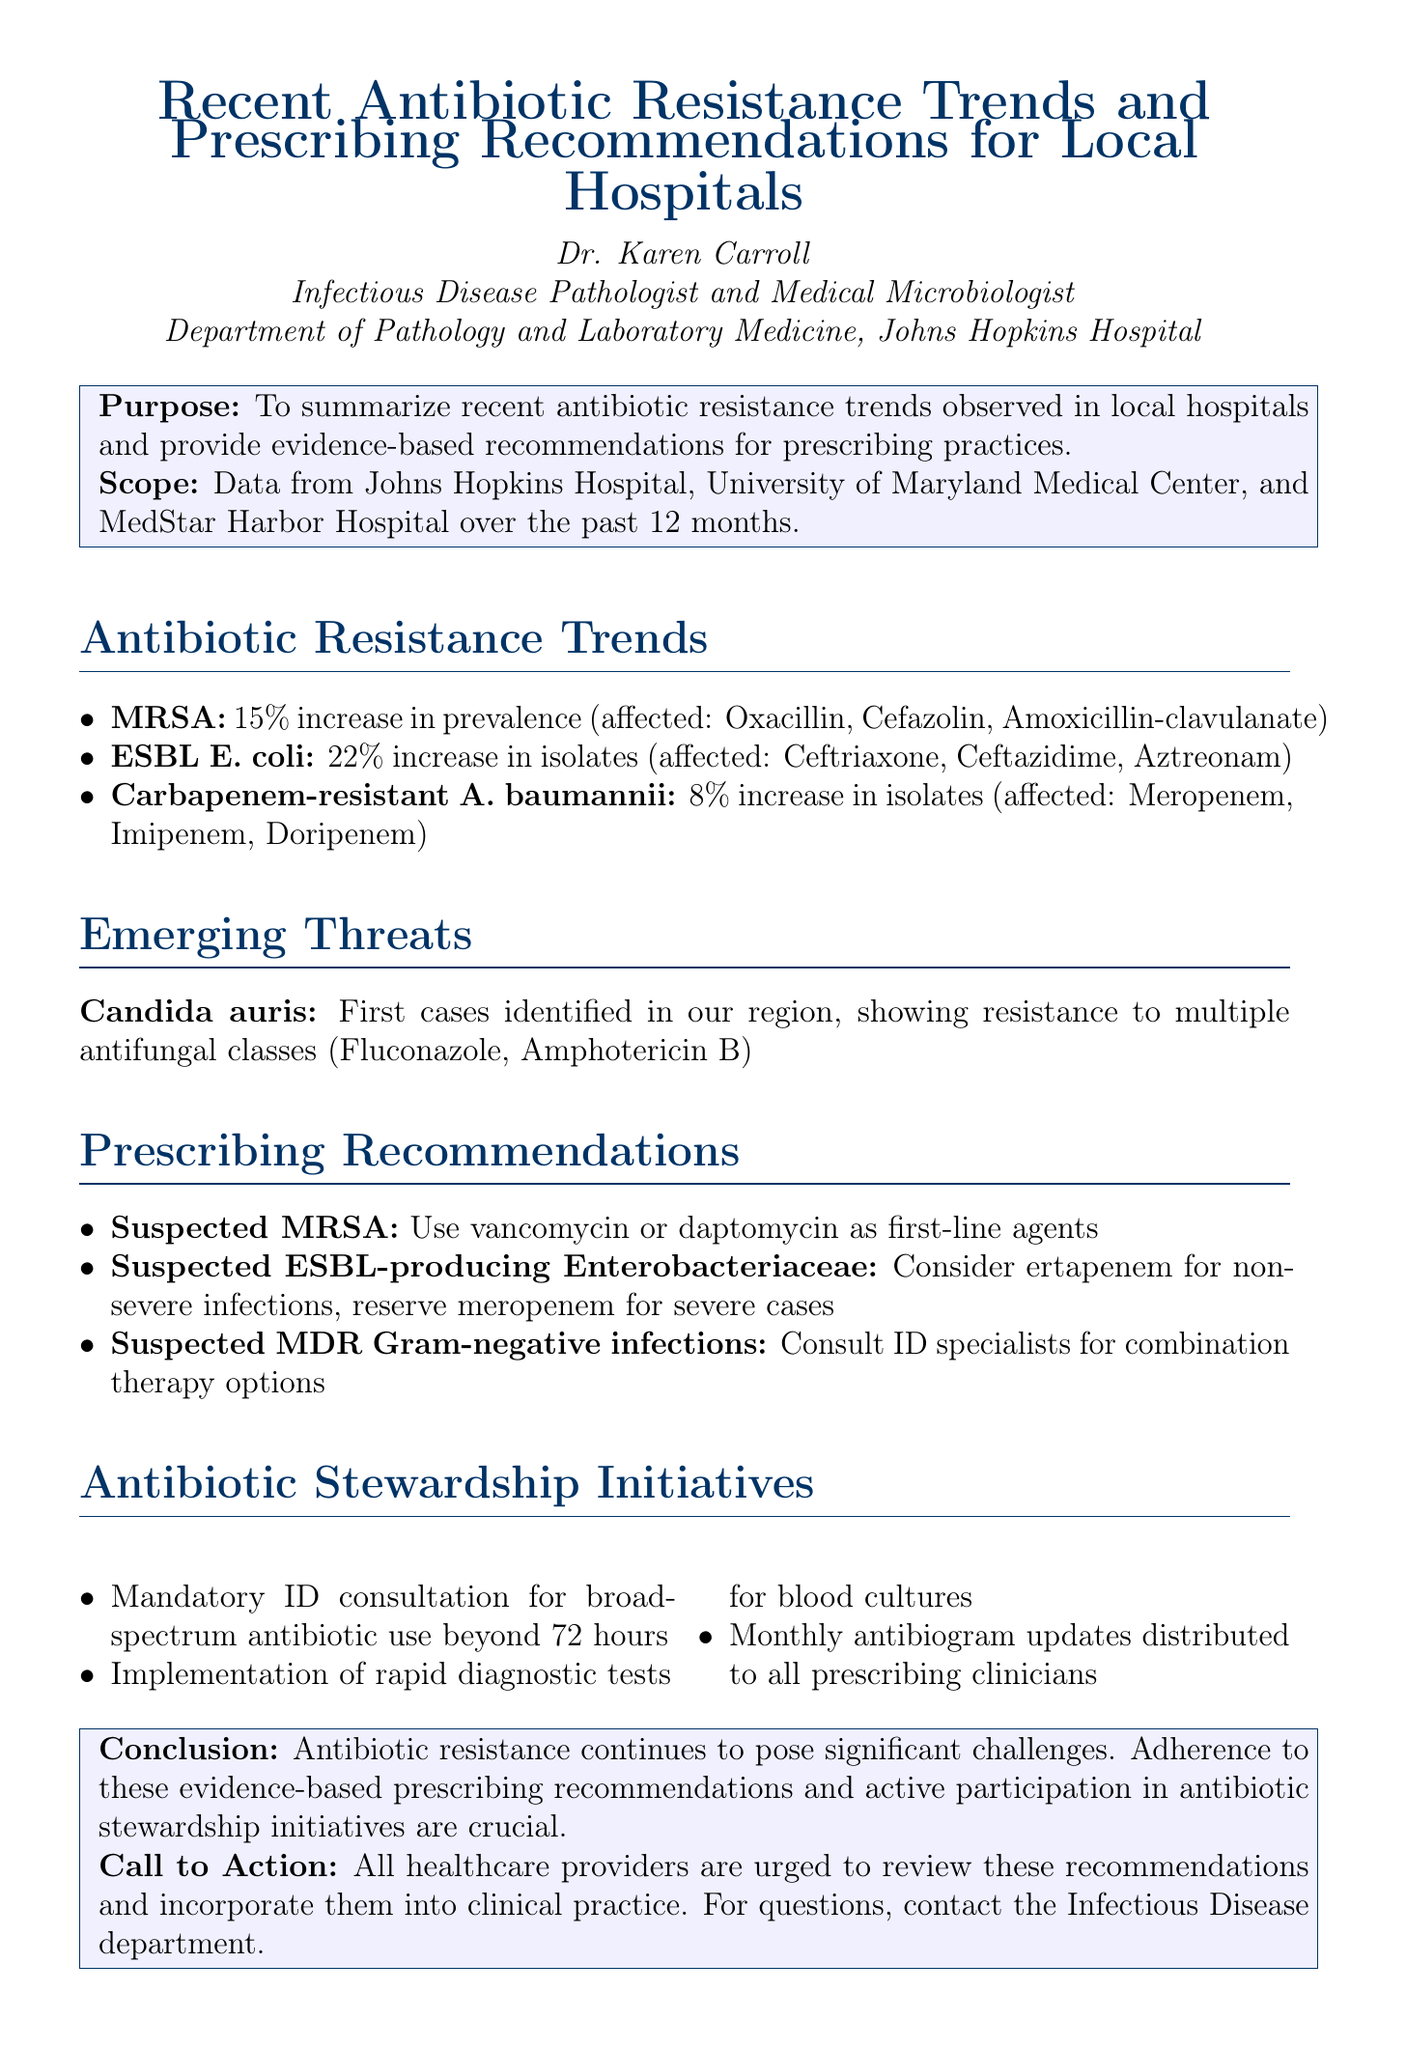What is the percentage increase in MRSA prevalence? The document states that there is a 15% increase in MRSA prevalence.
Answer: 15% What antibiotic showed an 8% increase in resistance? The memo mentions that carbapenem-resistant Acinetobacter baumannii had an 8% increase, affecting specific antibiotics.
Answer: Acinetobacter baumannii What is the first-line agent recommended for suspected MRSA infections? The memo recommends using vancomycin or daptomycin as first-line agents for suspected MRSA infections.
Answer: Vancomycin or daptomycin How many local hospitals were included in the data scope? The document states that data was collected from three local hospitals over the past year.
Answer: Three What is the main concern regarding Candida auris? The document highlights the concern about Candida auris due to its resistance to multiple antifungal classes.
Answer: Resistance to multiple antifungal classes What initiative aims to reduce unnecessary prolonged courses of broad-spectrum antibiotics? The document mentions a mandatory infectious disease consultation for broad-spectrum antibiotic use beyond 72 hours.
Answer: Mandatory infectious disease consultation What is the recommended action for management of suspected multidrug-resistant Gram-negative infections? The memo suggests consulting infectious disease specialists for combination therapy options as the recommended action.
Answer: Consult infectious disease specialists What is the call to action stated in the conclusion? The call to action urges all healthcare providers to review the recommendations and incorporate them into clinical practice.
Answer: Review and incorporate recommendations into clinical practice What document type is this summary classified as? This document is a memo summarizing findings and providing recommendations.
Answer: Memo 